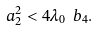<formula> <loc_0><loc_0><loc_500><loc_500>a _ { 2 } ^ { 2 } < 4 \lambda _ { 0 } \ b _ { 4 } .</formula> 